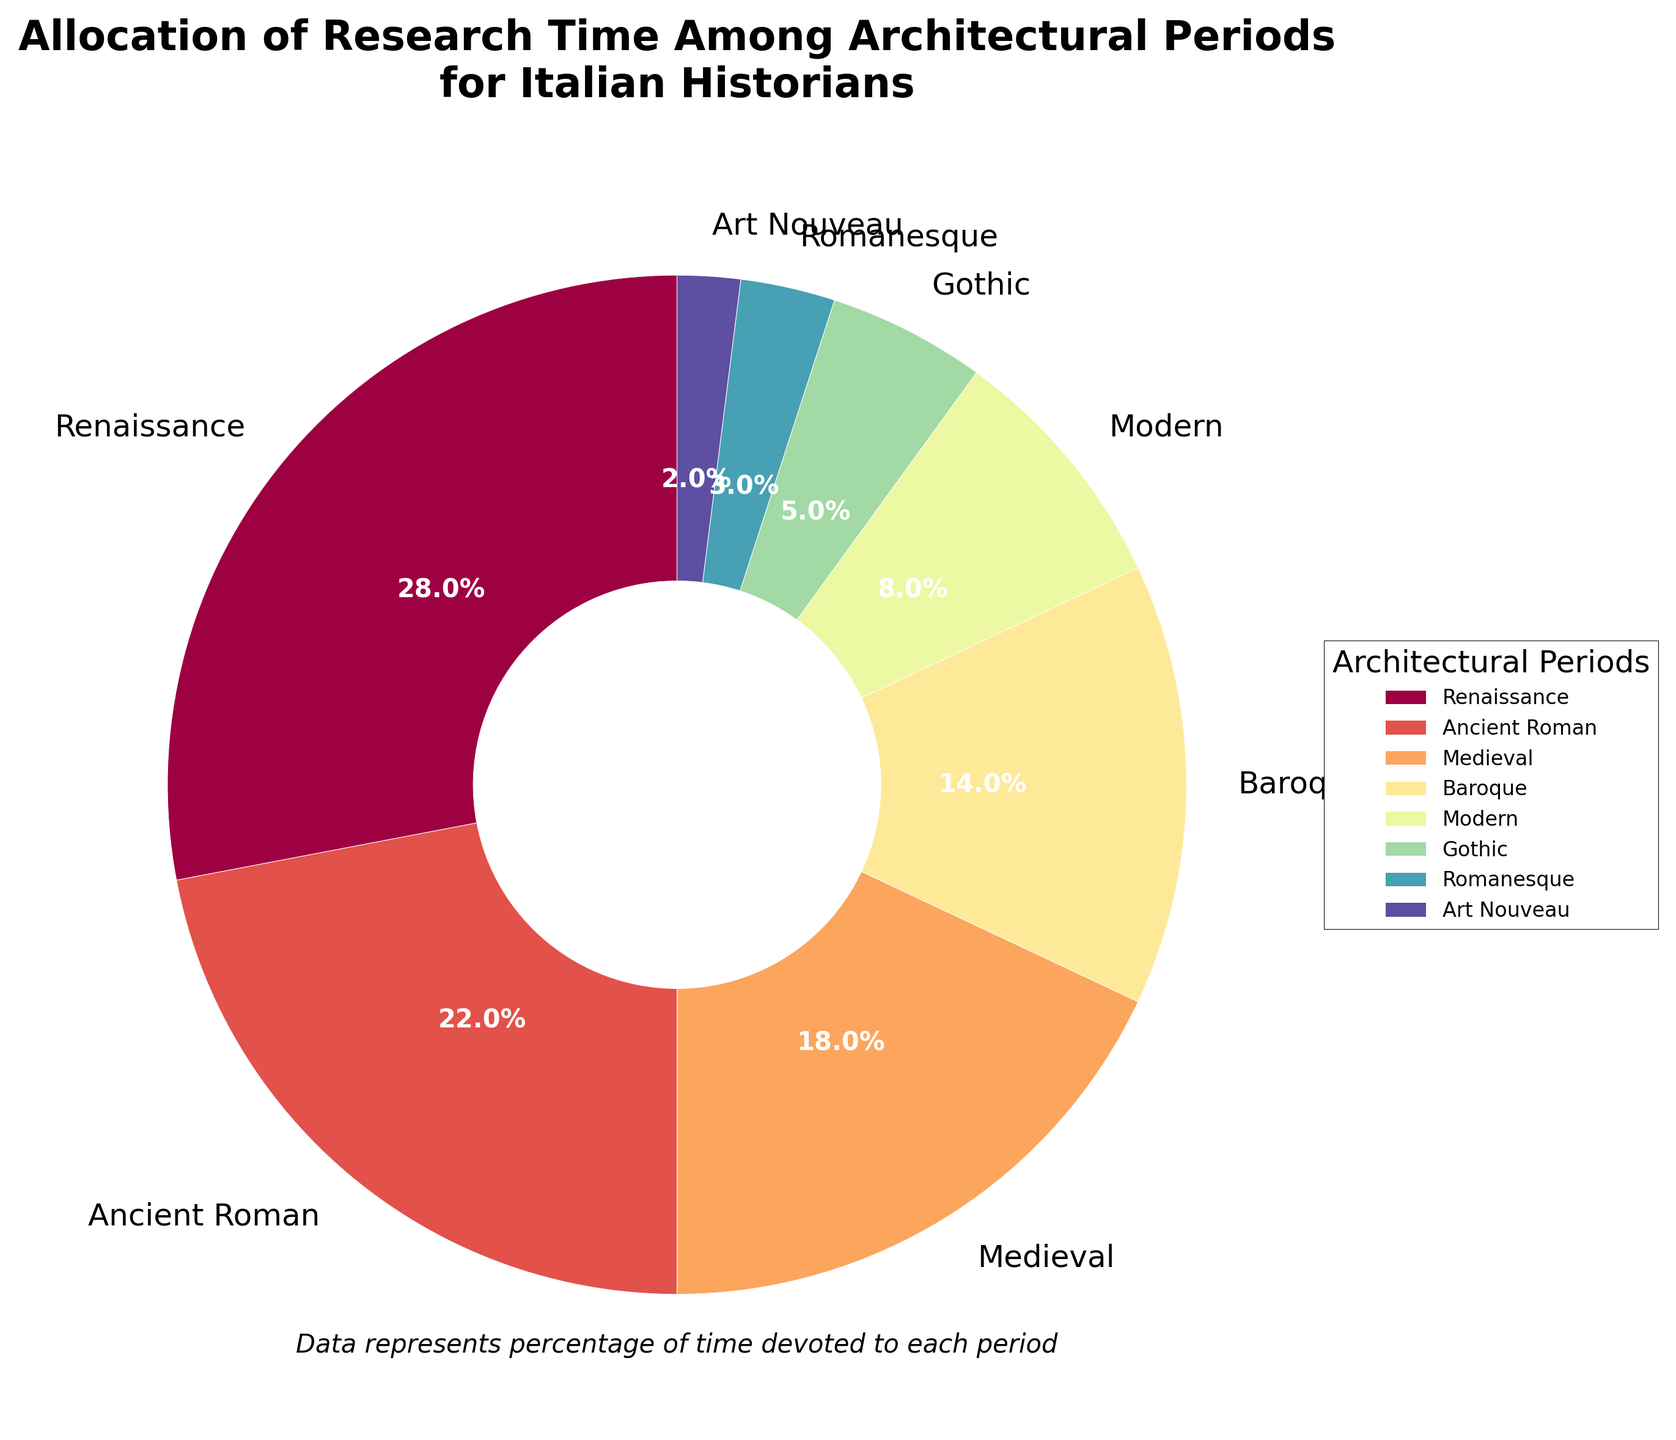What percentage of research time is allocated to Renaissance and Baroque periods combined? Add the percentages for Renaissance (28%) and Baroque (14%): 28 + 14 = 42%
Answer: 42% Which architectural period has a lower percentage of research time, Gothic or Romanesque? Compare the percentages for Gothic (5%) and Romanesque (3%): 3% < 5%, so Romanesque has a lower percentage.
Answer: Romanesque What is the difference in research time between Ancient Roman and Modern periods? Subtract the percentage for Modern (8%) from Ancient Roman (22%): 22 - 8 = 14%
Answer: 14% Which two periods together account for the highest percentage of research time, and what is that percentage? The two highest percentages are Renaissance (28%) and Ancient Roman (22%). Combined, they account for 28 + 22 = 50%
Answer: Renaissance and Ancient Roman, 50% Is the percentage of research time for the Medieval period greater than that for both Baroque and Modern periods combined? Add the percentages for Baroque (14%) and Modern (8%): 14 + 8 = 22%. Compare with Medieval (18%): 18% < 22%
Answer: No What color is used to represent the Art Nouveau period in the pie chart? The exact color may vary, but it is a distinct segment with a small wedge near the smallest percentages. Typically, specific coloration data may vary within viewers.
Answer: Varies How many architectural periods have a research allocation of 5% or less? Count the periods with 5% or less: Gothic (5%), Romanesque (3%), Art Nouveau (2%). Total is 3 periods.
Answer: 3 What is the percentage difference between the Renaissance and Gothic periods? Subtract the percentage for Gothic (5%) from Renaissance (28%): 28 - 5 = 23%
Answer: 23% Is the combined research time for Medieval and Gothic periods greater than that for Renaissance alone? Add the percentages for Medieval (18%) and Gothic (5%): 18 + 5 = 23%. Compare with Renaissance (28%): 23% < 28%
Answer: No 